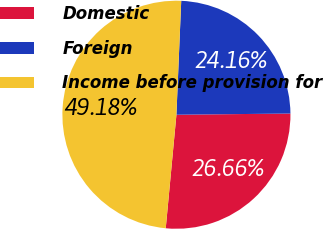<chart> <loc_0><loc_0><loc_500><loc_500><pie_chart><fcel>Domestic<fcel>Foreign<fcel>Income before provision for<nl><fcel>26.66%<fcel>24.16%<fcel>49.18%<nl></chart> 